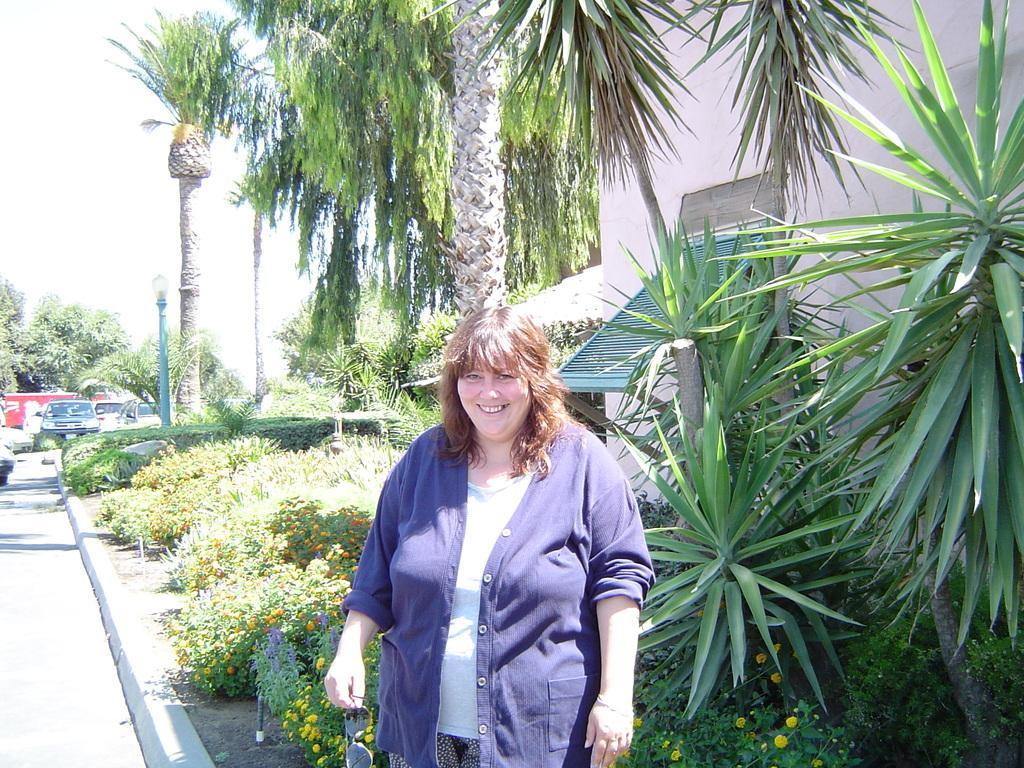Describe this image in one or two sentences. In this picture we can see a woman standing in front of a tree and smiling at someone. In the background we can see a garden and vehicles. 